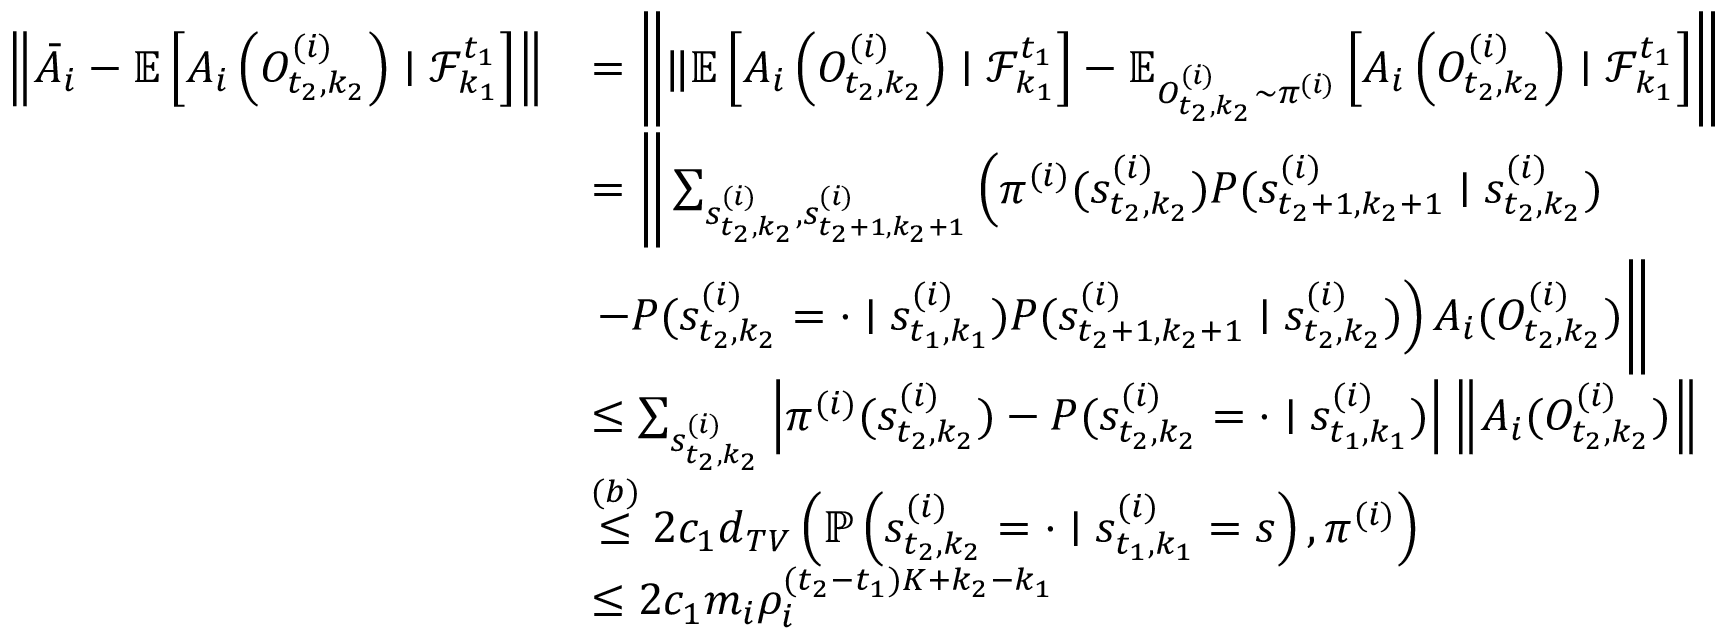Convert formula to latex. <formula><loc_0><loc_0><loc_500><loc_500>\begin{array} { r l } { \left \| \bar { A } _ { i } - \mathbb { E } \left [ A _ { i } \left ( O _ { t _ { 2 } , k _ { 2 } } ^ { ( i ) } \right ) | \mathcal { F } _ { k _ { 1 } } ^ { t _ { 1 } } \right ] \right \| } & { = \left \| \| \mathbb { E } \left [ A _ { i } \left ( O _ { t _ { 2 } , k _ { 2 } } ^ { ( i ) } \right ) | \mathcal { F } _ { k _ { 1 } } ^ { t _ { 1 } } \right ] - \mathbb { E } _ { O _ { t _ { 2 } , k _ { 2 } } ^ { ( i ) } \sim \pi ^ { ( i ) } } \left [ A _ { i } \left ( O _ { t _ { 2 } , k _ { 2 } } ^ { ( i ) } \right ) | \mathcal { F } _ { k _ { 1 } } ^ { t _ { 1 } } \right ] \right \| } \\ & { = \left \| \sum _ { s _ { t _ { 2 } , k _ { 2 } } ^ { ( i ) } , s _ { t _ { 2 } + 1 , k _ { 2 } + 1 } ^ { ( i ) } } \left ( \pi ^ { ( i ) } ( s _ { t _ { 2 } , k _ { 2 } } ^ { ( i ) } ) P ( s _ { t _ { 2 } + 1 , k _ { 2 } + 1 } ^ { ( i ) } | s _ { t _ { 2 } , k _ { 2 } } ^ { ( i ) } ) } \\ & { - P ( s _ { t _ { 2 } , k _ { 2 } } ^ { ( i ) } = \cdot | s _ { t _ { 1 } , k _ { 1 } } ^ { ( i ) } ) P ( s _ { t _ { 2 } + 1 , k _ { 2 } + 1 } ^ { ( i ) } | s _ { t _ { 2 } , k _ { 2 } } ^ { ( i ) } ) \right ) A _ { i } ( O _ { t _ { 2 } , k _ { 2 } } ^ { ( i ) } ) \right \| } \\ & { \leq \sum _ { s _ { t _ { 2 } , k _ { 2 } } ^ { ( i ) } } \left | \pi ^ { ( i ) } ( s _ { t _ { 2 } , k _ { 2 } } ^ { ( i ) } ) - P ( s _ { t _ { 2 } , k _ { 2 } } ^ { ( i ) } = \cdot | s _ { t _ { 1 } , k _ { 1 } } ^ { ( i ) } ) \right | \left \| A _ { i } ( O _ { t _ { 2 } , k _ { 2 } } ^ { ( i ) } ) \right \| } \\ & { \stackrel { ( b ) } \leq 2 c _ { 1 } d _ { T V } \left ( \mathbb { P } \left ( s _ { t _ { 2 } , k _ { 2 } } ^ { ( i ) } = \cdot | s _ { t _ { 1 } , k _ { 1 } } ^ { ( i ) } = s \right ) , \pi ^ { ( i ) } \right ) } \\ & { \leq 2 c _ { 1 } m _ { i } \rho _ { i } ^ { ( t _ { 2 } - t _ { 1 } ) K + k _ { 2 } - k _ { 1 } } } \end{array}</formula> 